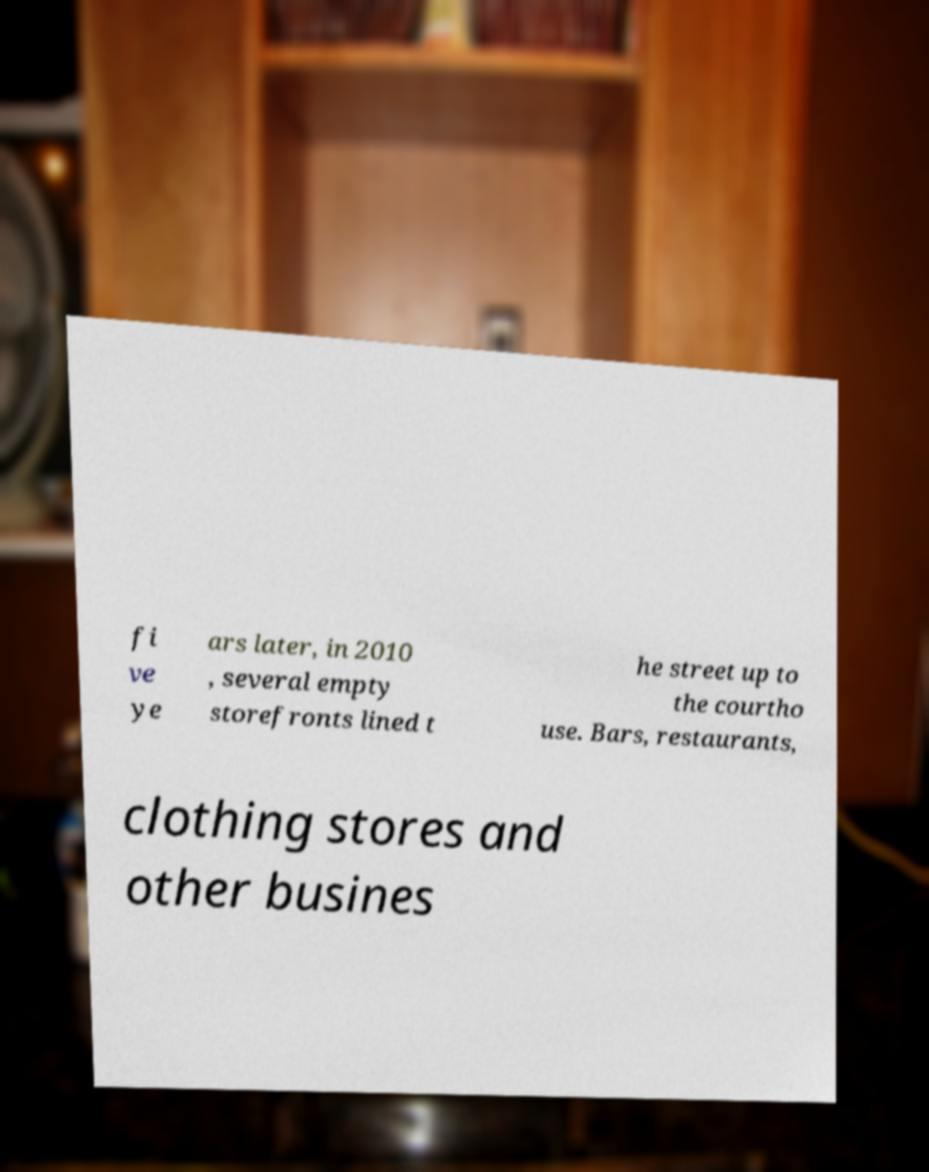I need the written content from this picture converted into text. Can you do that? fi ve ye ars later, in 2010 , several empty storefronts lined t he street up to the courtho use. Bars, restaurants, clothing stores and other busines 